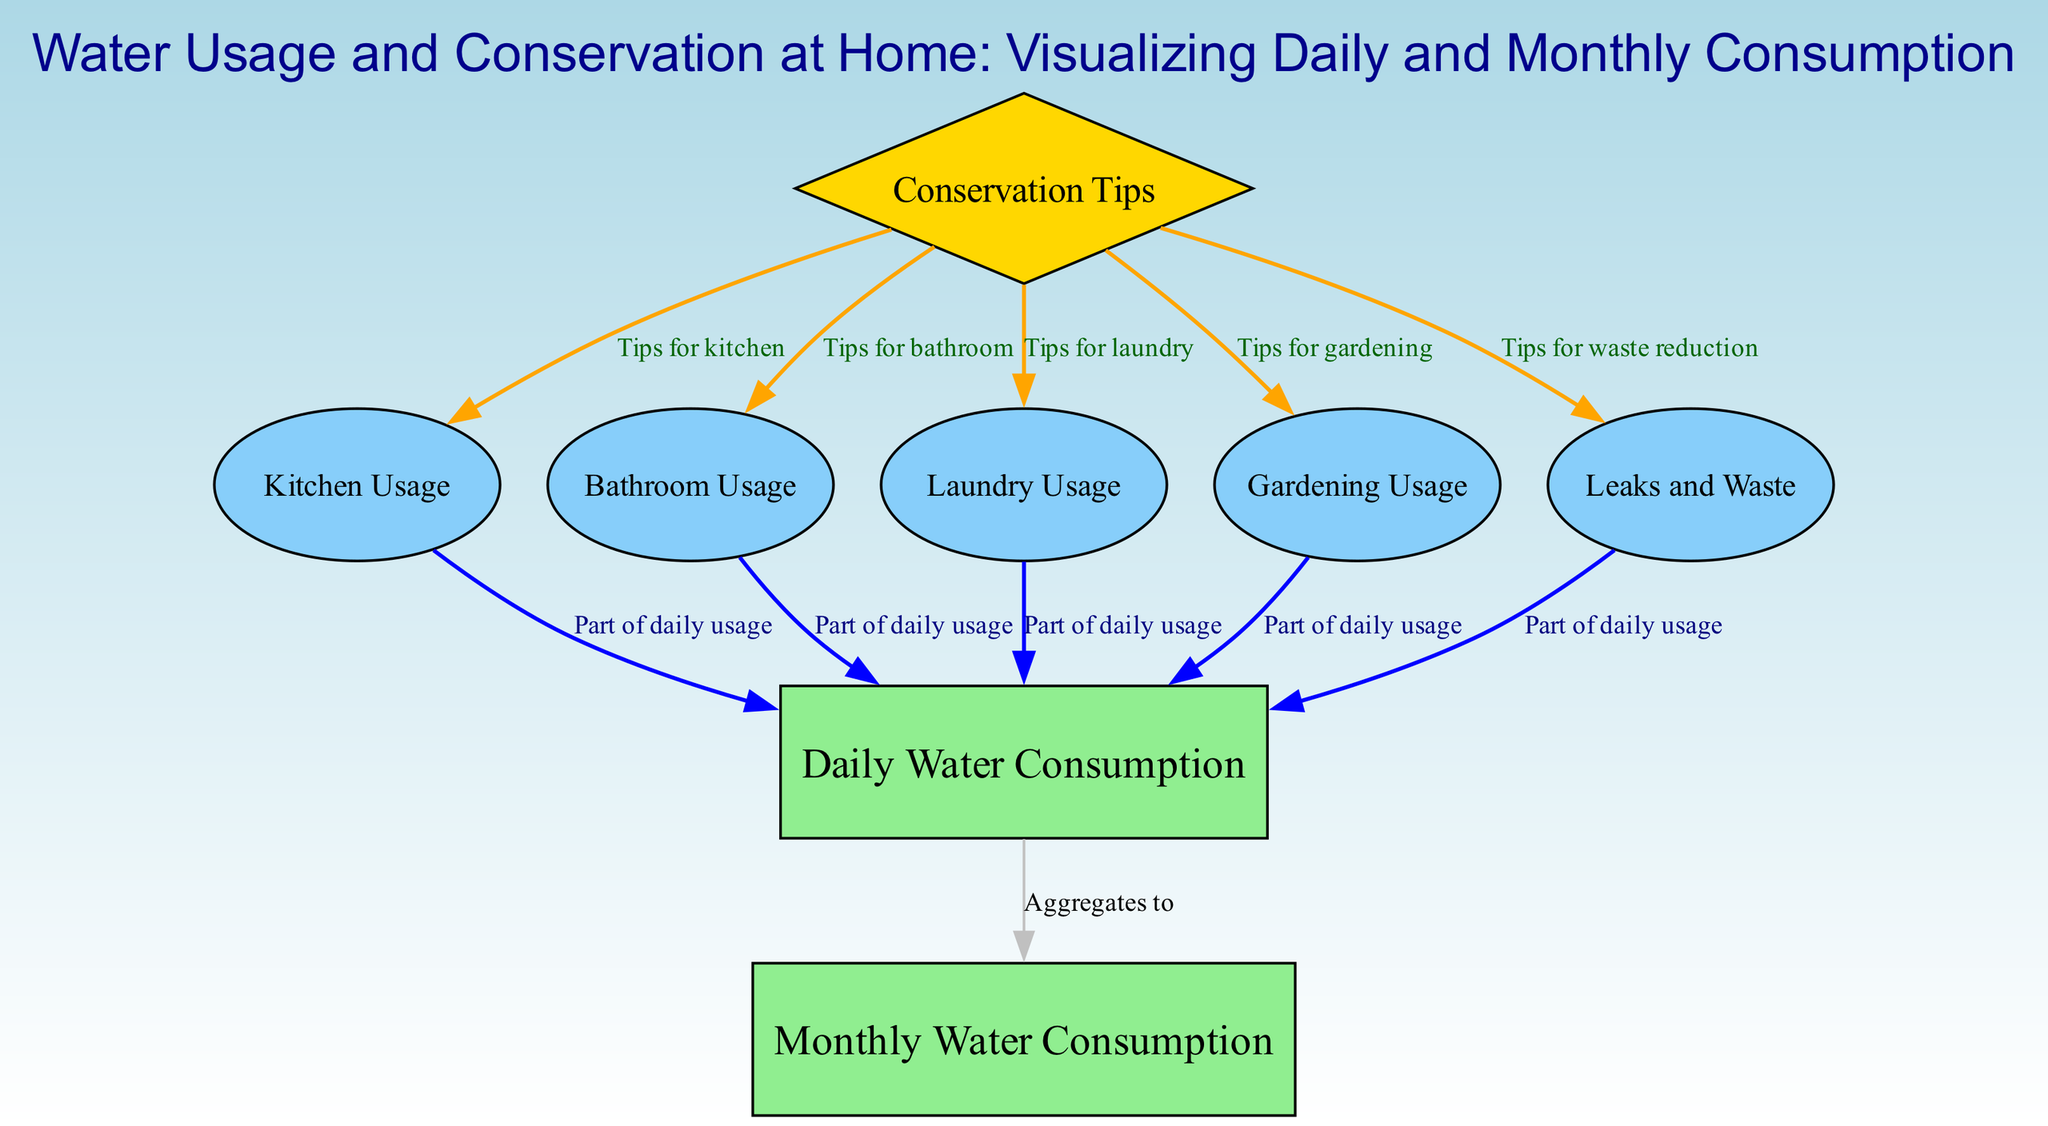What are the two main categories of water consumption? The diagram includes two main categories of water consumption which are "Daily Water Consumption" and "Monthly Water Consumption." These labels represent the overall tracking of water usage over these respective time frames.
Answer: Daily Water Consumption, Monthly Water Consumption How many specific usage categories are traced in daily water consumption? The diagram identifies five specific usage categories contributing to the daily water consumption: "Kitchen Usage," "Bathroom Usage," "Laundry Usage," "Gardening Usage," and "Leaks and Waste." This is summarized in the nodes directly connected to "Daily Water Consumption."
Answer: Five Which node provides tips for reducing water usage? The node labeled "Conservation Tips" is directly positioned as a diamond shape, indicating that it provides several suggestions for reducing water usage across different areas.
Answer: Conservation Tips From which nodes does the "Daily Water Consumption" aggregate? The "Daily Water Consumption" aggregates information from "Kitchen Usage," "Bathroom Usage," "Laundry Usage," "Gardening Usage," and "Leaks and Waste." This is shown by the direct edges connecting these nodes to the daily consumption node.
Answer: Kitchen Usage, Bathroom Usage, Laundry Usage, Gardening Usage, Leaks and Waste What is the relationship between "Conservation Tips" and "Leaky Water Usage"? The relationship indicates that the "Conservation Tips" node provides specific advice targeted toward reducing waste related to leaks. This is represented by a directed edge from "Conservation Tips" to "Leaks and Waste."
Answer: Tips for waste reduction Which usage category has the most direct connections? "Bathroom Usage," "Kitchen Usage," "Laundry Usage," and "Gardening Usage" each have direct connections to "Daily Water Consumption." These nodes indicate a significant portion of daily water usage, thus making them equally connected to the daily total.
Answer: Kitchen Usage, Bathroom Usage, Laundry Usage, Gardening Usage What color represents the "Conservation Tips" node in the diagram? The "Conservation Tips" node is rendered in gold according to the diagram's specified color-coding scheme for nodes, distinguishing it from others that may represent various consumption types.
Answer: Gold How many edges lead to the "Daily Water Consumption" node? There are six edges leading to the "Daily Water Consumption" node from other nodes. These edges represent the different types of water usage that contribute to the daily total.
Answer: Six Which node represents unintended water wastage? The node labeled "Leaks and Waste" signifies unintended water wastage that occurs during daily usage and is tracked separately.
Answer: Leaks and Waste 